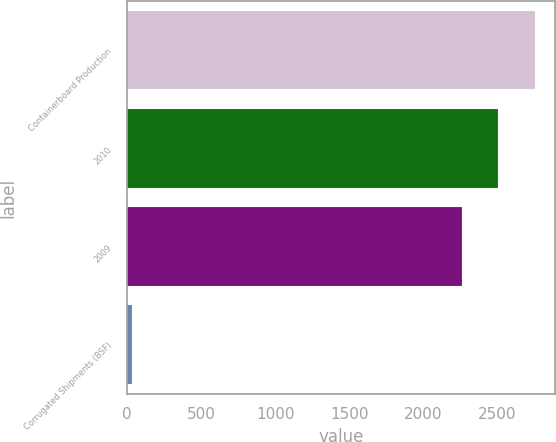Convert chart. <chart><loc_0><loc_0><loc_500><loc_500><bar_chart><fcel>Containerboard Production<fcel>2010<fcel>2009<fcel>Corrugated Shipments (BSF)<nl><fcel>2751.3<fcel>2504.65<fcel>2258<fcel>32.5<nl></chart> 